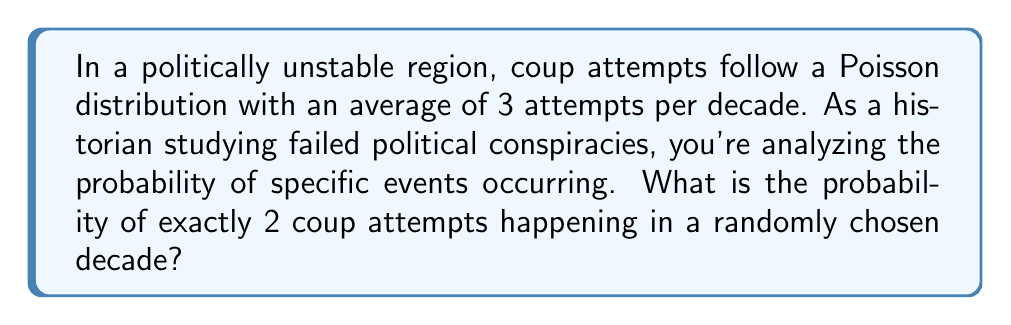Help me with this question. To solve this problem, we'll use the Poisson distribution formula:

$$P(X = k) = \frac{e^{-\lambda} \lambda^k}{k!}$$

Where:
- $\lambda$ is the average number of events in the given time period (3 attempts per decade)
- $k$ is the number of events we're interested in (2 coup attempts)
- $e$ is Euler's number (approximately 2.71828)

Let's plug in the values:

1) $\lambda = 3$
2) $k = 2$

$$P(X = 2) = \frac{e^{-3} 3^2}{2!}$$

3) Simplify the numerator:
   $$\frac{e^{-3} \cdot 9}{2}$$

4) Calculate $e^{-3}$ (you can use a calculator for this):
   $$\frac{0.0497871 \cdot 9}{2}$$

5) Multiply in the numerator:
   $$\frac{0.4480839}{2}$$

6) Divide:
   $$0.2240420$$

7) Round to four decimal places:
   $$0.2240$$

Therefore, the probability of exactly 2 coup attempts in a randomly chosen decade is approximately 0.2240 or 22.40%.
Answer: 0.2240 